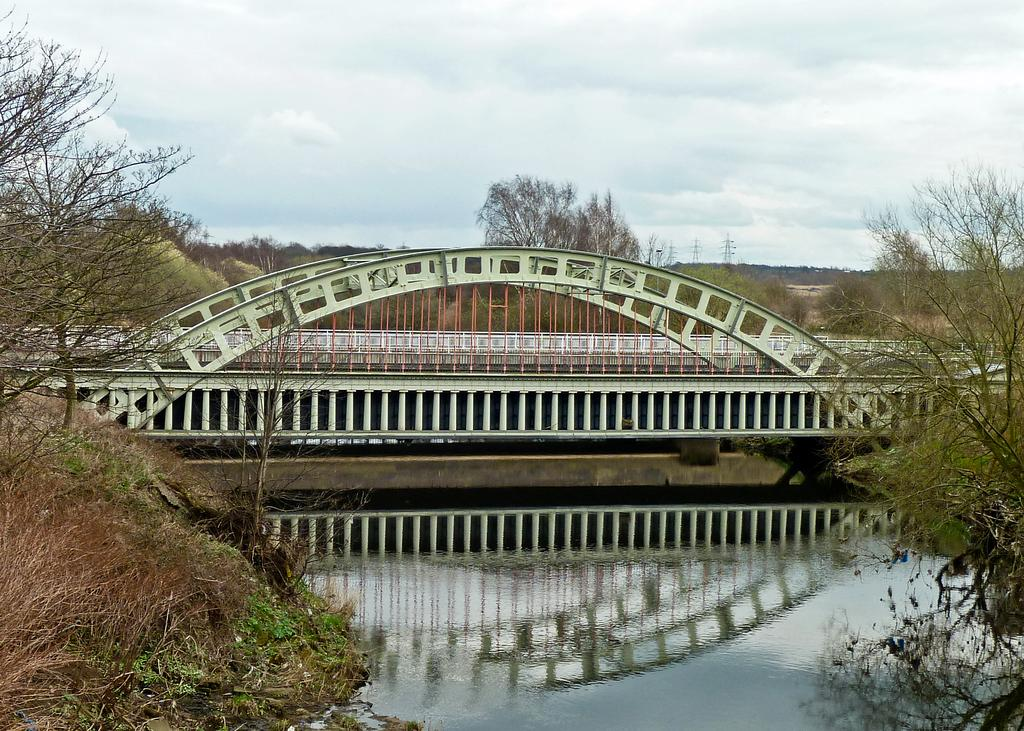What is visible in the image? Water, trees, a bridge, and clouds are visible in the image. Where are the trees located in the image? There are trees on both the left and right sides of the image. What is in the middle of the image? There is a bridge in the middle of the image. What can be seen in the sky in the background of the image? Clouds are visible in the sky in the background of the image. What type of work is being done on the bridge in the image? There is no indication of any work being done on the bridge in the image. 